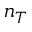<formula> <loc_0><loc_0><loc_500><loc_500>n _ { T }</formula> 